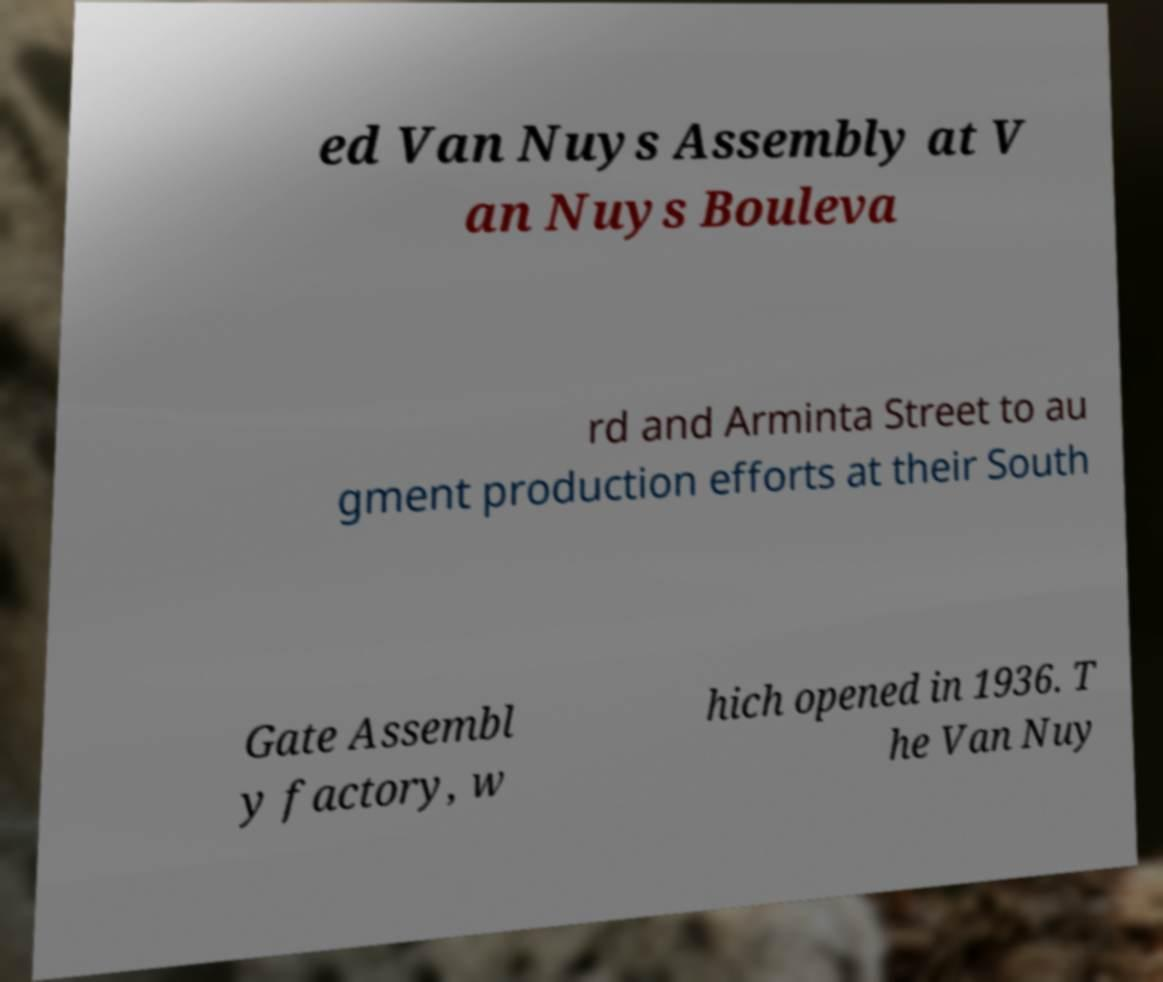Can you read and provide the text displayed in the image?This photo seems to have some interesting text. Can you extract and type it out for me? ed Van Nuys Assembly at V an Nuys Bouleva rd and Arminta Street to au gment production efforts at their South Gate Assembl y factory, w hich opened in 1936. T he Van Nuy 